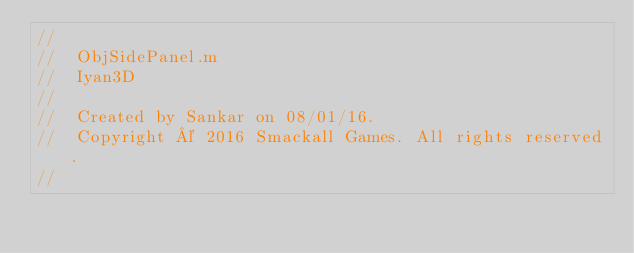Convert code to text. <code><loc_0><loc_0><loc_500><loc_500><_ObjectiveC_>//
//  ObjSidePanel.m
//  Iyan3D
//
//  Created by Sankar on 08/01/16.
//  Copyright © 2016 Smackall Games. All rights reserved.
//
</code> 